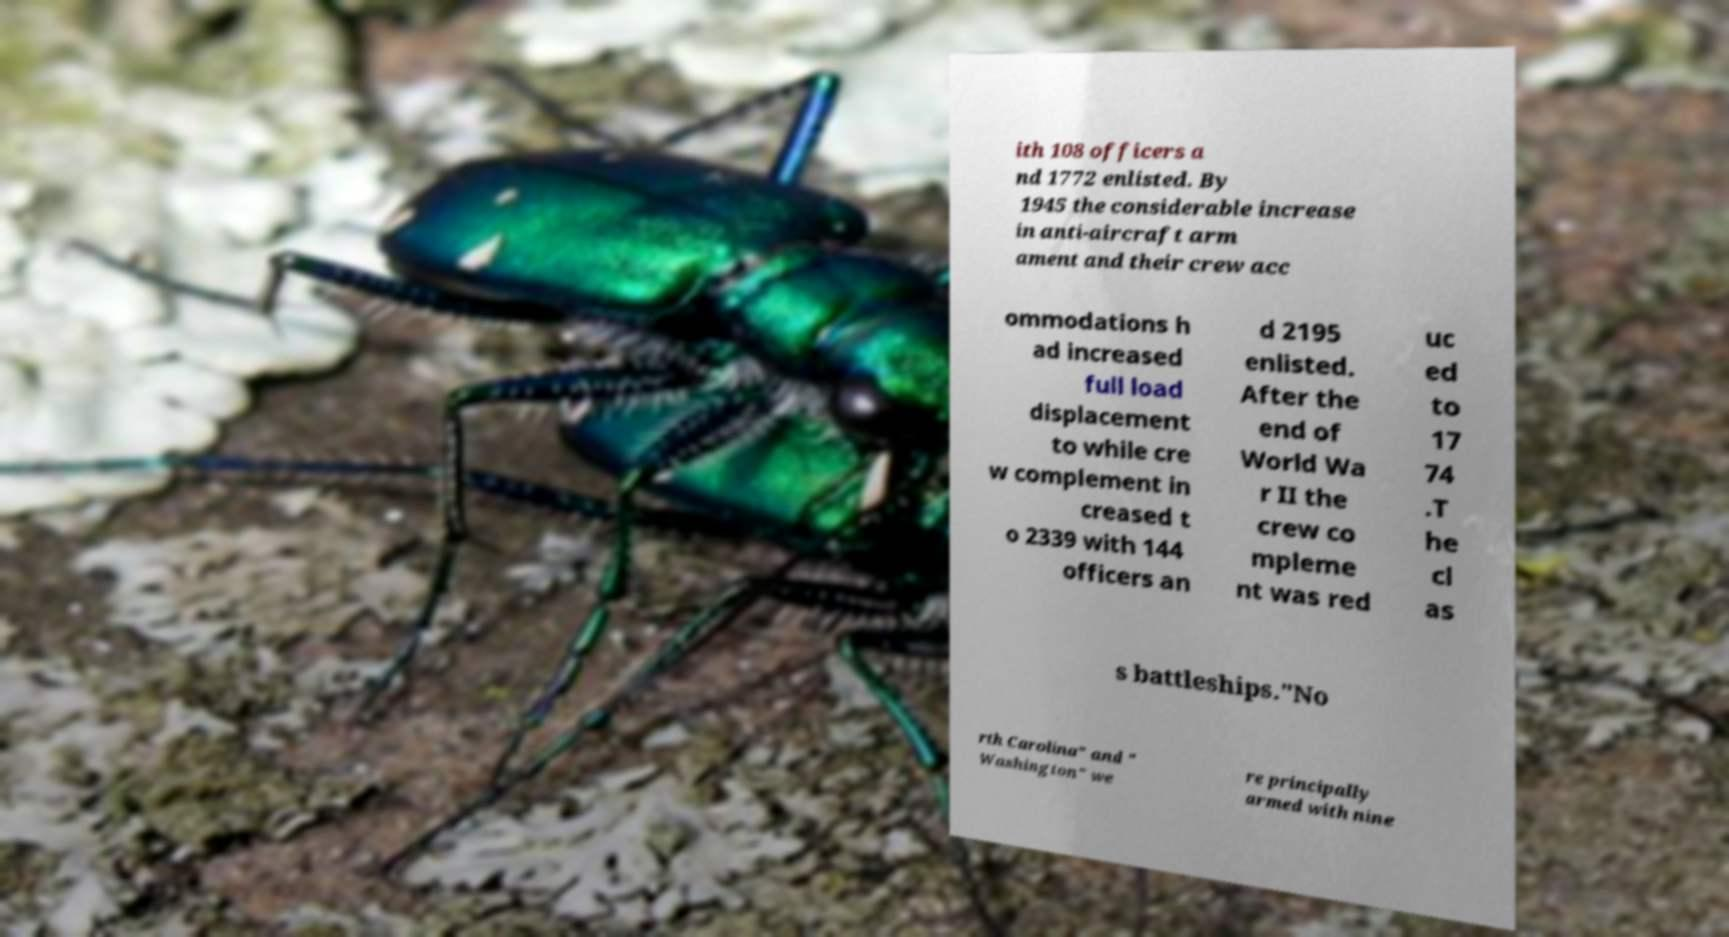Please identify and transcribe the text found in this image. ith 108 officers a nd 1772 enlisted. By 1945 the considerable increase in anti-aircraft arm ament and their crew acc ommodations h ad increased full load displacement to while cre w complement in creased t o 2339 with 144 officers an d 2195 enlisted. After the end of World Wa r II the crew co mpleme nt was red uc ed to 17 74 .T he cl as s battleships."No rth Carolina" and " Washington" we re principally armed with nine 